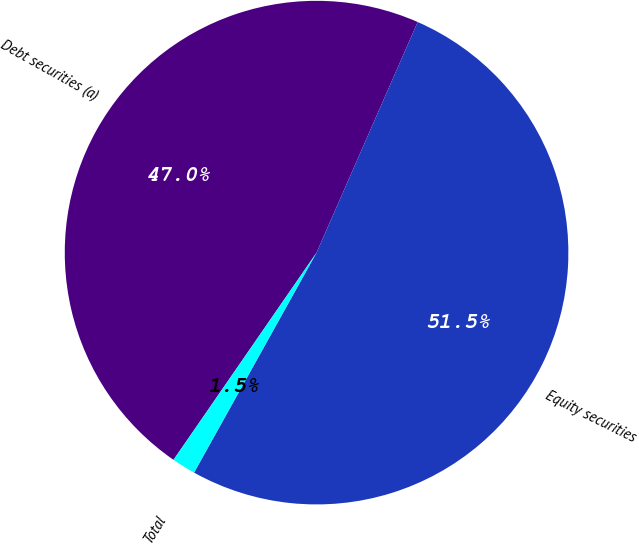Convert chart to OTSL. <chart><loc_0><loc_0><loc_500><loc_500><pie_chart><fcel>Debt securities (a)<fcel>Equity securities<fcel>Total<nl><fcel>46.96%<fcel>51.51%<fcel>1.53%<nl></chart> 